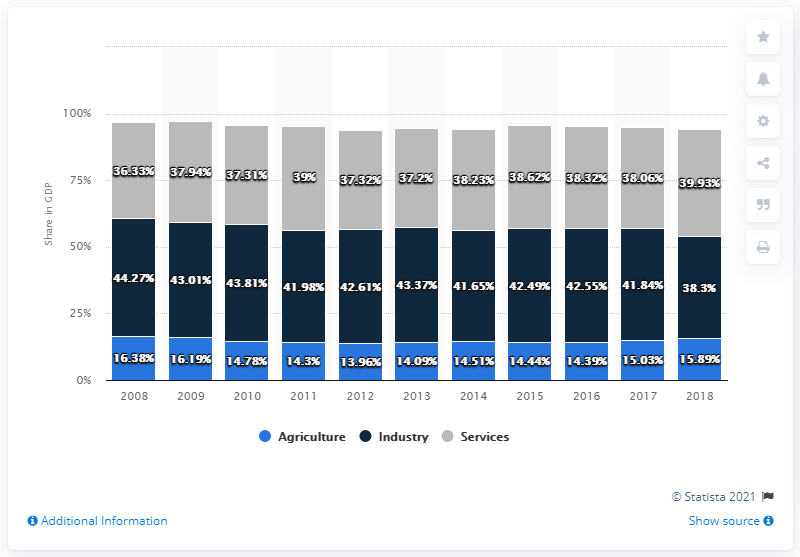List a handful of essential elements in this visual. In 2018, the agriculture sector accounted for 22.41% of Bhutan's GDP, while the industry sector accounted for the remaining 77.59%. According to data from the year 2017, the share of services in Bhutan's Gross Domestic Product (GDP) was 38.06%. 